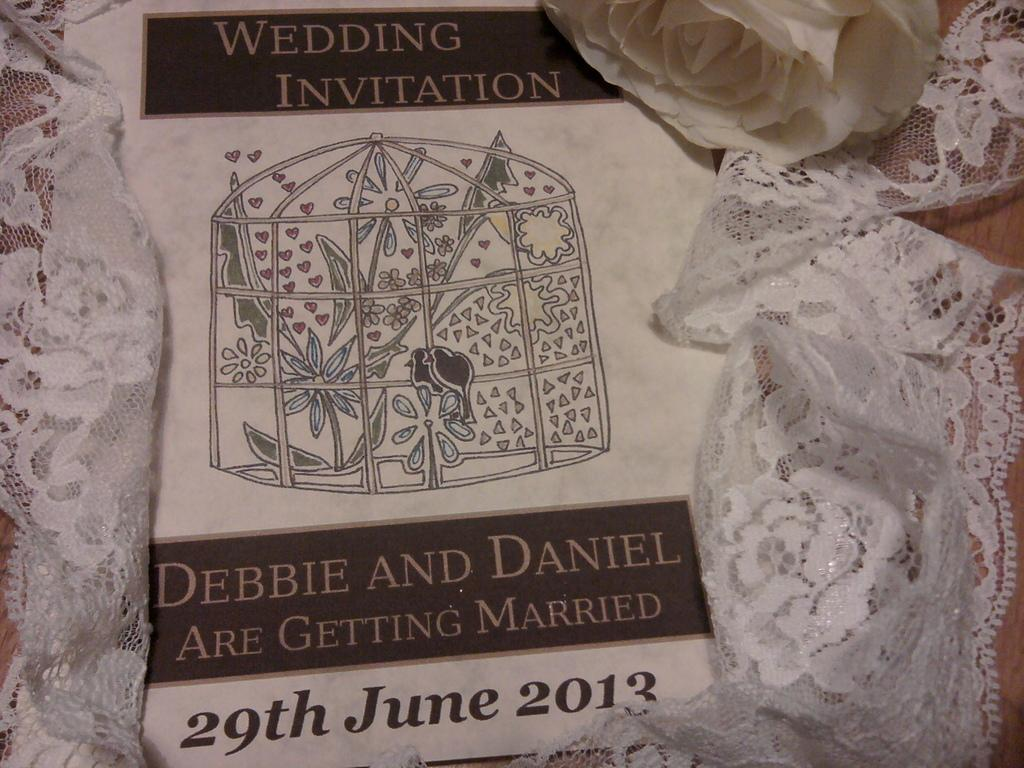What is the color of the pamphlet in the image? The pamphlet in the image is white. What type of object can be seen besides the pamphlet? There is a flower and cloth in the image. Can you tell me how the actor starts the scene in the image? There is no actor or scene in the image, as it only features a white color pamphlet, a flower, and cloth. 